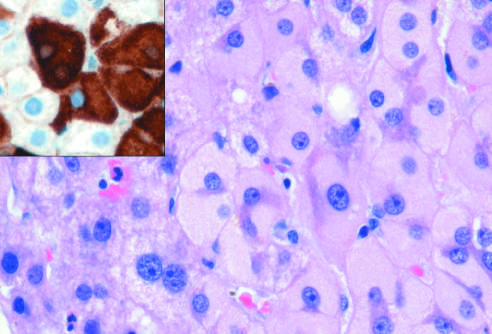how are ground-glass hepatocytes in chronic hepatitis b caused?
Answer the question using a single word or phrase. Accumulation of hepatitis b surface antigen 